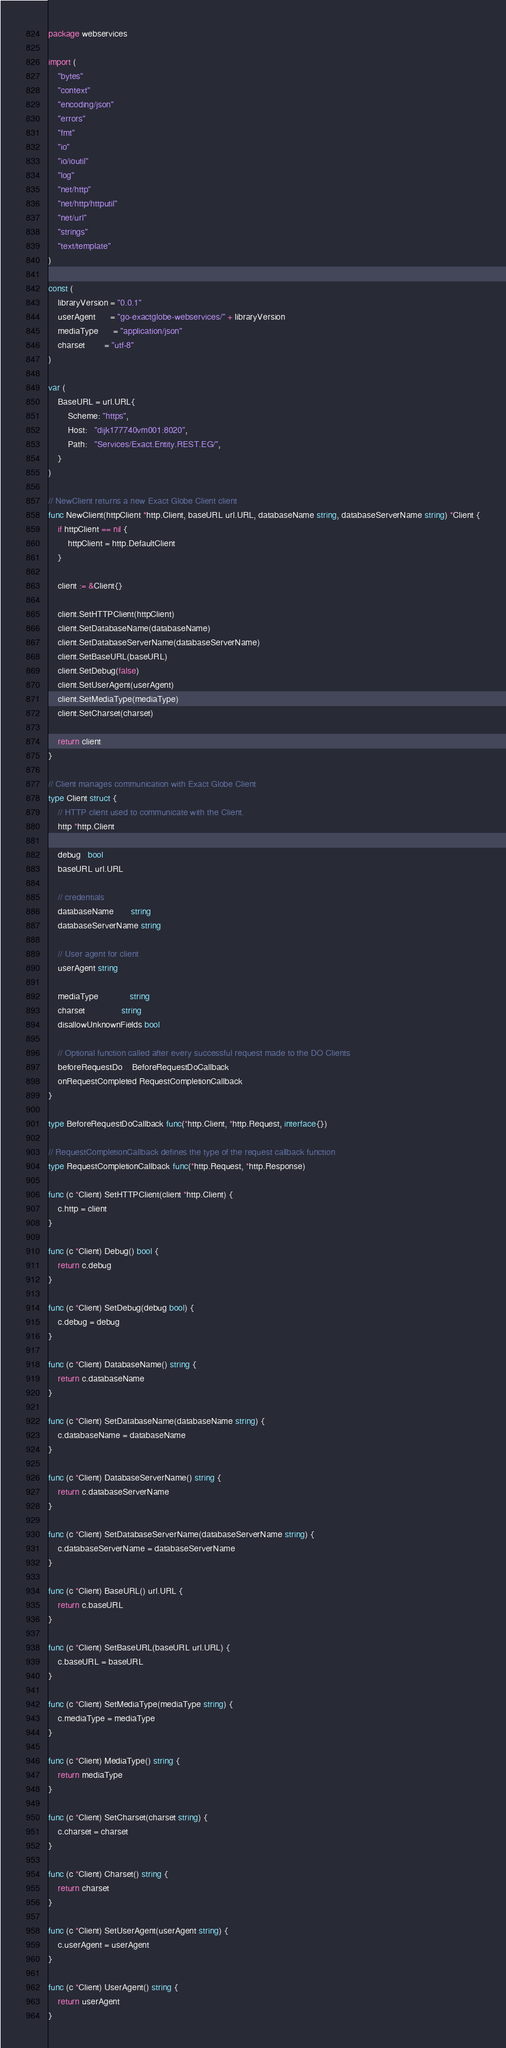Convert code to text. <code><loc_0><loc_0><loc_500><loc_500><_Go_>package webservices

import (
	"bytes"
	"context"
	"encoding/json"
	"errors"
	"fmt"
	"io"
	"io/ioutil"
	"log"
	"net/http"
	"net/http/httputil"
	"net/url"
	"strings"
	"text/template"
)

const (
	libraryVersion = "0.0.1"
	userAgent      = "go-exactglobe-webservices/" + libraryVersion
	mediaType      = "application/json"
	charset        = "utf-8"
)

var (
	BaseURL = url.URL{
		Scheme: "https",
		Host:   "dijk177740vm001:8020",
		Path:   "Services/Exact.Entity.REST.EG/",
	}
)

// NewClient returns a new Exact Globe Client client
func NewClient(httpClient *http.Client, baseURL url.URL, databaseName string, databaseServerName string) *Client {
	if httpClient == nil {
		httpClient = http.DefaultClient
	}

	client := &Client{}

	client.SetHTTPClient(httpClient)
	client.SetDatabaseName(databaseName)
	client.SetDatabaseServerName(databaseServerName)
	client.SetBaseURL(baseURL)
	client.SetDebug(false)
	client.SetUserAgent(userAgent)
	client.SetMediaType(mediaType)
	client.SetCharset(charset)

	return client
}

// Client manages communication with Exact Globe Client
type Client struct {
	// HTTP client used to communicate with the Client.
	http *http.Client

	debug   bool
	baseURL url.URL

	// credentials
	databaseName       string
	databaseServerName string

	// User agent for client
	userAgent string

	mediaType             string
	charset               string
	disallowUnknownFields bool

	// Optional function called after every successful request made to the DO Clients
	beforeRequestDo    BeforeRequestDoCallback
	onRequestCompleted RequestCompletionCallback
}

type BeforeRequestDoCallback func(*http.Client, *http.Request, interface{})

// RequestCompletionCallback defines the type of the request callback function
type RequestCompletionCallback func(*http.Request, *http.Response)

func (c *Client) SetHTTPClient(client *http.Client) {
	c.http = client
}

func (c *Client) Debug() bool {
	return c.debug
}

func (c *Client) SetDebug(debug bool) {
	c.debug = debug
}

func (c *Client) DatabaseName() string {
	return c.databaseName
}

func (c *Client) SetDatabaseName(databaseName string) {
	c.databaseName = databaseName
}

func (c *Client) DatabaseServerName() string {
	return c.databaseServerName
}

func (c *Client) SetDatabaseServerName(databaseServerName string) {
	c.databaseServerName = databaseServerName
}

func (c *Client) BaseURL() url.URL {
	return c.baseURL
}

func (c *Client) SetBaseURL(baseURL url.URL) {
	c.baseURL = baseURL
}

func (c *Client) SetMediaType(mediaType string) {
	c.mediaType = mediaType
}

func (c *Client) MediaType() string {
	return mediaType
}

func (c *Client) SetCharset(charset string) {
	c.charset = charset
}

func (c *Client) Charset() string {
	return charset
}

func (c *Client) SetUserAgent(userAgent string) {
	c.userAgent = userAgent
}

func (c *Client) UserAgent() string {
	return userAgent
}
</code> 